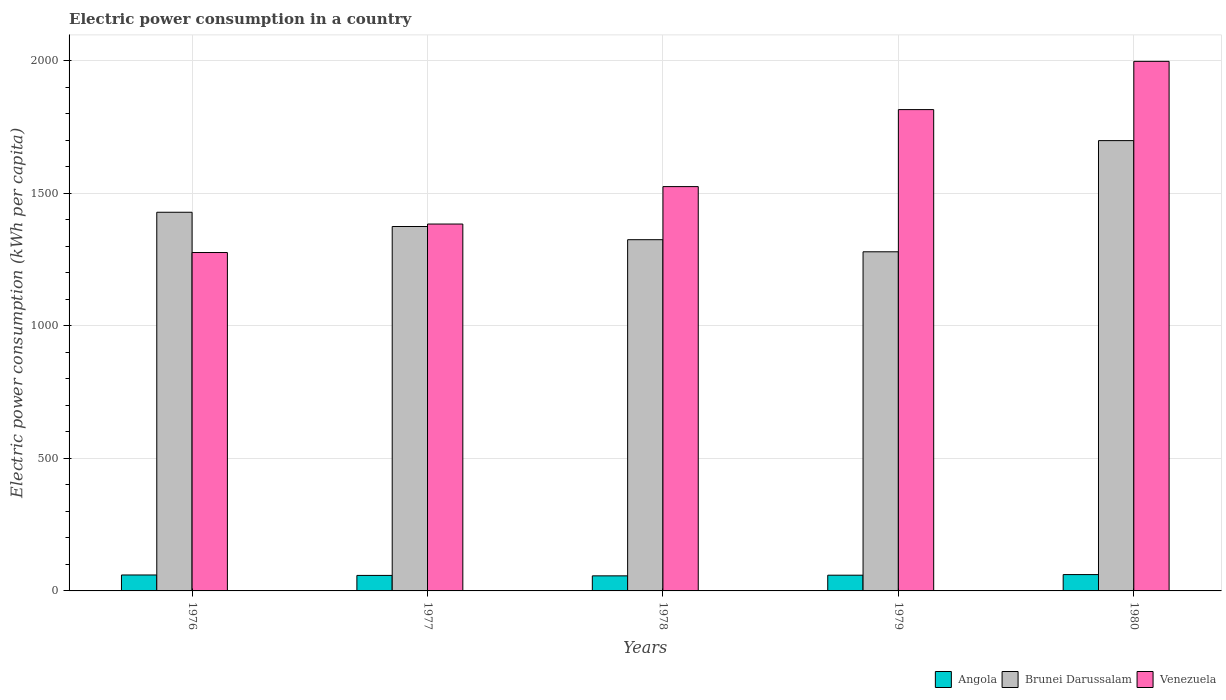How many different coloured bars are there?
Offer a terse response. 3. How many groups of bars are there?
Your answer should be very brief. 5. Are the number of bars per tick equal to the number of legend labels?
Keep it short and to the point. Yes. What is the label of the 1st group of bars from the left?
Your answer should be very brief. 1976. In how many cases, is the number of bars for a given year not equal to the number of legend labels?
Your response must be concise. 0. What is the electric power consumption in in Angola in 1977?
Give a very brief answer. 58.52. Across all years, what is the maximum electric power consumption in in Brunei Darussalam?
Make the answer very short. 1698.98. Across all years, what is the minimum electric power consumption in in Venezuela?
Offer a terse response. 1276.79. In which year was the electric power consumption in in Venezuela minimum?
Offer a very short reply. 1976. What is the total electric power consumption in in Angola in the graph?
Give a very brief answer. 296.52. What is the difference between the electric power consumption in in Venezuela in 1977 and that in 1979?
Offer a very short reply. -431.78. What is the difference between the electric power consumption in in Venezuela in 1978 and the electric power consumption in in Angola in 1979?
Offer a very short reply. 1466.13. What is the average electric power consumption in in Angola per year?
Your answer should be compact. 59.3. In the year 1979, what is the difference between the electric power consumption in in Venezuela and electric power consumption in in Brunei Darussalam?
Keep it short and to the point. 536.46. In how many years, is the electric power consumption in in Brunei Darussalam greater than 1100 kWh per capita?
Your answer should be compact. 5. What is the ratio of the electric power consumption in in Brunei Darussalam in 1977 to that in 1979?
Your response must be concise. 1.07. What is the difference between the highest and the second highest electric power consumption in in Brunei Darussalam?
Offer a very short reply. 270.26. What is the difference between the highest and the lowest electric power consumption in in Brunei Darussalam?
Ensure brevity in your answer.  419.44. In how many years, is the electric power consumption in in Angola greater than the average electric power consumption in in Angola taken over all years?
Your answer should be very brief. 3. What does the 3rd bar from the left in 1978 represents?
Your answer should be very brief. Venezuela. What does the 3rd bar from the right in 1979 represents?
Provide a succinct answer. Angola. Are all the bars in the graph horizontal?
Your answer should be compact. No. Are the values on the major ticks of Y-axis written in scientific E-notation?
Ensure brevity in your answer.  No. Does the graph contain any zero values?
Your answer should be very brief. No. Does the graph contain grids?
Offer a terse response. Yes. How are the legend labels stacked?
Your answer should be compact. Horizontal. What is the title of the graph?
Ensure brevity in your answer.  Electric power consumption in a country. Does "Indonesia" appear as one of the legend labels in the graph?
Your answer should be compact. No. What is the label or title of the X-axis?
Ensure brevity in your answer.  Years. What is the label or title of the Y-axis?
Your answer should be very brief. Electric power consumption (kWh per capita). What is the Electric power consumption (kWh per capita) in Angola in 1976?
Your answer should be compact. 60.14. What is the Electric power consumption (kWh per capita) in Brunei Darussalam in 1976?
Offer a very short reply. 1428.72. What is the Electric power consumption (kWh per capita) in Venezuela in 1976?
Keep it short and to the point. 1276.79. What is the Electric power consumption (kWh per capita) in Angola in 1977?
Give a very brief answer. 58.52. What is the Electric power consumption (kWh per capita) of Brunei Darussalam in 1977?
Your response must be concise. 1374.94. What is the Electric power consumption (kWh per capita) of Venezuela in 1977?
Provide a short and direct response. 1384.22. What is the Electric power consumption (kWh per capita) in Angola in 1978?
Offer a terse response. 56.89. What is the Electric power consumption (kWh per capita) of Brunei Darussalam in 1978?
Ensure brevity in your answer.  1325.15. What is the Electric power consumption (kWh per capita) of Venezuela in 1978?
Keep it short and to the point. 1525.48. What is the Electric power consumption (kWh per capita) in Angola in 1979?
Offer a terse response. 59.35. What is the Electric power consumption (kWh per capita) in Brunei Darussalam in 1979?
Ensure brevity in your answer.  1279.54. What is the Electric power consumption (kWh per capita) of Venezuela in 1979?
Your answer should be compact. 1816. What is the Electric power consumption (kWh per capita) in Angola in 1980?
Offer a very short reply. 61.62. What is the Electric power consumption (kWh per capita) of Brunei Darussalam in 1980?
Your answer should be very brief. 1698.98. What is the Electric power consumption (kWh per capita) of Venezuela in 1980?
Your answer should be very brief. 1998.06. Across all years, what is the maximum Electric power consumption (kWh per capita) of Angola?
Keep it short and to the point. 61.62. Across all years, what is the maximum Electric power consumption (kWh per capita) of Brunei Darussalam?
Your answer should be very brief. 1698.98. Across all years, what is the maximum Electric power consumption (kWh per capita) of Venezuela?
Your response must be concise. 1998.06. Across all years, what is the minimum Electric power consumption (kWh per capita) in Angola?
Your answer should be compact. 56.89. Across all years, what is the minimum Electric power consumption (kWh per capita) in Brunei Darussalam?
Offer a very short reply. 1279.54. Across all years, what is the minimum Electric power consumption (kWh per capita) in Venezuela?
Provide a short and direct response. 1276.79. What is the total Electric power consumption (kWh per capita) in Angola in the graph?
Provide a succinct answer. 296.52. What is the total Electric power consumption (kWh per capita) in Brunei Darussalam in the graph?
Give a very brief answer. 7107.32. What is the total Electric power consumption (kWh per capita) of Venezuela in the graph?
Offer a terse response. 8000.54. What is the difference between the Electric power consumption (kWh per capita) in Angola in 1976 and that in 1977?
Offer a very short reply. 1.62. What is the difference between the Electric power consumption (kWh per capita) in Brunei Darussalam in 1976 and that in 1977?
Provide a short and direct response. 53.78. What is the difference between the Electric power consumption (kWh per capita) of Venezuela in 1976 and that in 1977?
Your answer should be compact. -107.43. What is the difference between the Electric power consumption (kWh per capita) in Angola in 1976 and that in 1978?
Provide a short and direct response. 3.25. What is the difference between the Electric power consumption (kWh per capita) in Brunei Darussalam in 1976 and that in 1978?
Your response must be concise. 103.57. What is the difference between the Electric power consumption (kWh per capita) of Venezuela in 1976 and that in 1978?
Provide a short and direct response. -248.69. What is the difference between the Electric power consumption (kWh per capita) of Angola in 1976 and that in 1979?
Offer a terse response. 0.79. What is the difference between the Electric power consumption (kWh per capita) of Brunei Darussalam in 1976 and that in 1979?
Offer a very short reply. 149.18. What is the difference between the Electric power consumption (kWh per capita) of Venezuela in 1976 and that in 1979?
Make the answer very short. -539.21. What is the difference between the Electric power consumption (kWh per capita) in Angola in 1976 and that in 1980?
Provide a succinct answer. -1.48. What is the difference between the Electric power consumption (kWh per capita) of Brunei Darussalam in 1976 and that in 1980?
Keep it short and to the point. -270.26. What is the difference between the Electric power consumption (kWh per capita) of Venezuela in 1976 and that in 1980?
Offer a terse response. -721.27. What is the difference between the Electric power consumption (kWh per capita) in Angola in 1977 and that in 1978?
Ensure brevity in your answer.  1.64. What is the difference between the Electric power consumption (kWh per capita) in Brunei Darussalam in 1977 and that in 1978?
Your answer should be very brief. 49.79. What is the difference between the Electric power consumption (kWh per capita) in Venezuela in 1977 and that in 1978?
Make the answer very short. -141.26. What is the difference between the Electric power consumption (kWh per capita) in Angola in 1977 and that in 1979?
Give a very brief answer. -0.83. What is the difference between the Electric power consumption (kWh per capita) in Brunei Darussalam in 1977 and that in 1979?
Give a very brief answer. 95.4. What is the difference between the Electric power consumption (kWh per capita) of Venezuela in 1977 and that in 1979?
Your answer should be compact. -431.77. What is the difference between the Electric power consumption (kWh per capita) in Angola in 1977 and that in 1980?
Your answer should be compact. -3.09. What is the difference between the Electric power consumption (kWh per capita) in Brunei Darussalam in 1977 and that in 1980?
Your answer should be compact. -324.04. What is the difference between the Electric power consumption (kWh per capita) of Venezuela in 1977 and that in 1980?
Offer a terse response. -613.83. What is the difference between the Electric power consumption (kWh per capita) in Angola in 1978 and that in 1979?
Keep it short and to the point. -2.46. What is the difference between the Electric power consumption (kWh per capita) in Brunei Darussalam in 1978 and that in 1979?
Make the answer very short. 45.61. What is the difference between the Electric power consumption (kWh per capita) of Venezuela in 1978 and that in 1979?
Provide a short and direct response. -290.52. What is the difference between the Electric power consumption (kWh per capita) in Angola in 1978 and that in 1980?
Provide a succinct answer. -4.73. What is the difference between the Electric power consumption (kWh per capita) of Brunei Darussalam in 1978 and that in 1980?
Offer a very short reply. -373.83. What is the difference between the Electric power consumption (kWh per capita) in Venezuela in 1978 and that in 1980?
Your answer should be very brief. -472.58. What is the difference between the Electric power consumption (kWh per capita) in Angola in 1979 and that in 1980?
Ensure brevity in your answer.  -2.27. What is the difference between the Electric power consumption (kWh per capita) of Brunei Darussalam in 1979 and that in 1980?
Give a very brief answer. -419.44. What is the difference between the Electric power consumption (kWh per capita) in Venezuela in 1979 and that in 1980?
Ensure brevity in your answer.  -182.06. What is the difference between the Electric power consumption (kWh per capita) of Angola in 1976 and the Electric power consumption (kWh per capita) of Brunei Darussalam in 1977?
Provide a short and direct response. -1314.8. What is the difference between the Electric power consumption (kWh per capita) in Angola in 1976 and the Electric power consumption (kWh per capita) in Venezuela in 1977?
Make the answer very short. -1324.08. What is the difference between the Electric power consumption (kWh per capita) of Brunei Darussalam in 1976 and the Electric power consumption (kWh per capita) of Venezuela in 1977?
Your answer should be compact. 44.49. What is the difference between the Electric power consumption (kWh per capita) in Angola in 1976 and the Electric power consumption (kWh per capita) in Brunei Darussalam in 1978?
Your answer should be compact. -1265.01. What is the difference between the Electric power consumption (kWh per capita) of Angola in 1976 and the Electric power consumption (kWh per capita) of Venezuela in 1978?
Your answer should be very brief. -1465.34. What is the difference between the Electric power consumption (kWh per capita) in Brunei Darussalam in 1976 and the Electric power consumption (kWh per capita) in Venezuela in 1978?
Provide a short and direct response. -96.76. What is the difference between the Electric power consumption (kWh per capita) of Angola in 1976 and the Electric power consumption (kWh per capita) of Brunei Darussalam in 1979?
Offer a very short reply. -1219.4. What is the difference between the Electric power consumption (kWh per capita) of Angola in 1976 and the Electric power consumption (kWh per capita) of Venezuela in 1979?
Provide a short and direct response. -1755.86. What is the difference between the Electric power consumption (kWh per capita) in Brunei Darussalam in 1976 and the Electric power consumption (kWh per capita) in Venezuela in 1979?
Offer a terse response. -387.28. What is the difference between the Electric power consumption (kWh per capita) of Angola in 1976 and the Electric power consumption (kWh per capita) of Brunei Darussalam in 1980?
Offer a very short reply. -1638.84. What is the difference between the Electric power consumption (kWh per capita) in Angola in 1976 and the Electric power consumption (kWh per capita) in Venezuela in 1980?
Ensure brevity in your answer.  -1937.91. What is the difference between the Electric power consumption (kWh per capita) of Brunei Darussalam in 1976 and the Electric power consumption (kWh per capita) of Venezuela in 1980?
Keep it short and to the point. -569.34. What is the difference between the Electric power consumption (kWh per capita) in Angola in 1977 and the Electric power consumption (kWh per capita) in Brunei Darussalam in 1978?
Provide a succinct answer. -1266.63. What is the difference between the Electric power consumption (kWh per capita) in Angola in 1977 and the Electric power consumption (kWh per capita) in Venezuela in 1978?
Give a very brief answer. -1466.96. What is the difference between the Electric power consumption (kWh per capita) in Brunei Darussalam in 1977 and the Electric power consumption (kWh per capita) in Venezuela in 1978?
Give a very brief answer. -150.54. What is the difference between the Electric power consumption (kWh per capita) in Angola in 1977 and the Electric power consumption (kWh per capita) in Brunei Darussalam in 1979?
Offer a terse response. -1221.02. What is the difference between the Electric power consumption (kWh per capita) of Angola in 1977 and the Electric power consumption (kWh per capita) of Venezuela in 1979?
Offer a terse response. -1757.47. What is the difference between the Electric power consumption (kWh per capita) in Brunei Darussalam in 1977 and the Electric power consumption (kWh per capita) in Venezuela in 1979?
Your answer should be compact. -441.06. What is the difference between the Electric power consumption (kWh per capita) of Angola in 1977 and the Electric power consumption (kWh per capita) of Brunei Darussalam in 1980?
Offer a very short reply. -1640.46. What is the difference between the Electric power consumption (kWh per capita) of Angola in 1977 and the Electric power consumption (kWh per capita) of Venezuela in 1980?
Give a very brief answer. -1939.53. What is the difference between the Electric power consumption (kWh per capita) of Brunei Darussalam in 1977 and the Electric power consumption (kWh per capita) of Venezuela in 1980?
Your response must be concise. -623.12. What is the difference between the Electric power consumption (kWh per capita) of Angola in 1978 and the Electric power consumption (kWh per capita) of Brunei Darussalam in 1979?
Ensure brevity in your answer.  -1222.65. What is the difference between the Electric power consumption (kWh per capita) of Angola in 1978 and the Electric power consumption (kWh per capita) of Venezuela in 1979?
Your answer should be compact. -1759.11. What is the difference between the Electric power consumption (kWh per capita) in Brunei Darussalam in 1978 and the Electric power consumption (kWh per capita) in Venezuela in 1979?
Make the answer very short. -490.85. What is the difference between the Electric power consumption (kWh per capita) in Angola in 1978 and the Electric power consumption (kWh per capita) in Brunei Darussalam in 1980?
Give a very brief answer. -1642.09. What is the difference between the Electric power consumption (kWh per capita) of Angola in 1978 and the Electric power consumption (kWh per capita) of Venezuela in 1980?
Offer a terse response. -1941.17. What is the difference between the Electric power consumption (kWh per capita) in Brunei Darussalam in 1978 and the Electric power consumption (kWh per capita) in Venezuela in 1980?
Make the answer very short. -672.91. What is the difference between the Electric power consumption (kWh per capita) of Angola in 1979 and the Electric power consumption (kWh per capita) of Brunei Darussalam in 1980?
Provide a short and direct response. -1639.63. What is the difference between the Electric power consumption (kWh per capita) in Angola in 1979 and the Electric power consumption (kWh per capita) in Venezuela in 1980?
Provide a succinct answer. -1938.71. What is the difference between the Electric power consumption (kWh per capita) of Brunei Darussalam in 1979 and the Electric power consumption (kWh per capita) of Venezuela in 1980?
Offer a terse response. -718.52. What is the average Electric power consumption (kWh per capita) of Angola per year?
Offer a terse response. 59.3. What is the average Electric power consumption (kWh per capita) of Brunei Darussalam per year?
Provide a short and direct response. 1421.46. What is the average Electric power consumption (kWh per capita) of Venezuela per year?
Ensure brevity in your answer.  1600.11. In the year 1976, what is the difference between the Electric power consumption (kWh per capita) of Angola and Electric power consumption (kWh per capita) of Brunei Darussalam?
Your answer should be very brief. -1368.58. In the year 1976, what is the difference between the Electric power consumption (kWh per capita) in Angola and Electric power consumption (kWh per capita) in Venezuela?
Your response must be concise. -1216.65. In the year 1976, what is the difference between the Electric power consumption (kWh per capita) in Brunei Darussalam and Electric power consumption (kWh per capita) in Venezuela?
Make the answer very short. 151.93. In the year 1977, what is the difference between the Electric power consumption (kWh per capita) in Angola and Electric power consumption (kWh per capita) in Brunei Darussalam?
Make the answer very short. -1316.42. In the year 1977, what is the difference between the Electric power consumption (kWh per capita) in Angola and Electric power consumption (kWh per capita) in Venezuela?
Give a very brief answer. -1325.7. In the year 1977, what is the difference between the Electric power consumption (kWh per capita) of Brunei Darussalam and Electric power consumption (kWh per capita) of Venezuela?
Give a very brief answer. -9.28. In the year 1978, what is the difference between the Electric power consumption (kWh per capita) of Angola and Electric power consumption (kWh per capita) of Brunei Darussalam?
Your answer should be compact. -1268.26. In the year 1978, what is the difference between the Electric power consumption (kWh per capita) in Angola and Electric power consumption (kWh per capita) in Venezuela?
Give a very brief answer. -1468.59. In the year 1978, what is the difference between the Electric power consumption (kWh per capita) of Brunei Darussalam and Electric power consumption (kWh per capita) of Venezuela?
Your response must be concise. -200.33. In the year 1979, what is the difference between the Electric power consumption (kWh per capita) in Angola and Electric power consumption (kWh per capita) in Brunei Darussalam?
Offer a terse response. -1220.19. In the year 1979, what is the difference between the Electric power consumption (kWh per capita) in Angola and Electric power consumption (kWh per capita) in Venezuela?
Your answer should be compact. -1756.65. In the year 1979, what is the difference between the Electric power consumption (kWh per capita) in Brunei Darussalam and Electric power consumption (kWh per capita) in Venezuela?
Your answer should be very brief. -536.46. In the year 1980, what is the difference between the Electric power consumption (kWh per capita) in Angola and Electric power consumption (kWh per capita) in Brunei Darussalam?
Give a very brief answer. -1637.36. In the year 1980, what is the difference between the Electric power consumption (kWh per capita) in Angola and Electric power consumption (kWh per capita) in Venezuela?
Keep it short and to the point. -1936.44. In the year 1980, what is the difference between the Electric power consumption (kWh per capita) of Brunei Darussalam and Electric power consumption (kWh per capita) of Venezuela?
Give a very brief answer. -299.08. What is the ratio of the Electric power consumption (kWh per capita) in Angola in 1976 to that in 1977?
Your answer should be compact. 1.03. What is the ratio of the Electric power consumption (kWh per capita) of Brunei Darussalam in 1976 to that in 1977?
Your response must be concise. 1.04. What is the ratio of the Electric power consumption (kWh per capita) of Venezuela in 1976 to that in 1977?
Give a very brief answer. 0.92. What is the ratio of the Electric power consumption (kWh per capita) of Angola in 1976 to that in 1978?
Offer a very short reply. 1.06. What is the ratio of the Electric power consumption (kWh per capita) of Brunei Darussalam in 1976 to that in 1978?
Offer a very short reply. 1.08. What is the ratio of the Electric power consumption (kWh per capita) of Venezuela in 1976 to that in 1978?
Make the answer very short. 0.84. What is the ratio of the Electric power consumption (kWh per capita) of Angola in 1976 to that in 1979?
Offer a very short reply. 1.01. What is the ratio of the Electric power consumption (kWh per capita) in Brunei Darussalam in 1976 to that in 1979?
Your response must be concise. 1.12. What is the ratio of the Electric power consumption (kWh per capita) in Venezuela in 1976 to that in 1979?
Your response must be concise. 0.7. What is the ratio of the Electric power consumption (kWh per capita) in Brunei Darussalam in 1976 to that in 1980?
Provide a short and direct response. 0.84. What is the ratio of the Electric power consumption (kWh per capita) in Venezuela in 1976 to that in 1980?
Offer a terse response. 0.64. What is the ratio of the Electric power consumption (kWh per capita) in Angola in 1977 to that in 1978?
Offer a very short reply. 1.03. What is the ratio of the Electric power consumption (kWh per capita) of Brunei Darussalam in 1977 to that in 1978?
Make the answer very short. 1.04. What is the ratio of the Electric power consumption (kWh per capita) of Venezuela in 1977 to that in 1978?
Give a very brief answer. 0.91. What is the ratio of the Electric power consumption (kWh per capita) of Angola in 1977 to that in 1979?
Your response must be concise. 0.99. What is the ratio of the Electric power consumption (kWh per capita) in Brunei Darussalam in 1977 to that in 1979?
Make the answer very short. 1.07. What is the ratio of the Electric power consumption (kWh per capita) of Venezuela in 1977 to that in 1979?
Offer a terse response. 0.76. What is the ratio of the Electric power consumption (kWh per capita) of Angola in 1977 to that in 1980?
Make the answer very short. 0.95. What is the ratio of the Electric power consumption (kWh per capita) in Brunei Darussalam in 1977 to that in 1980?
Ensure brevity in your answer.  0.81. What is the ratio of the Electric power consumption (kWh per capita) of Venezuela in 1977 to that in 1980?
Ensure brevity in your answer.  0.69. What is the ratio of the Electric power consumption (kWh per capita) of Angola in 1978 to that in 1979?
Offer a very short reply. 0.96. What is the ratio of the Electric power consumption (kWh per capita) in Brunei Darussalam in 1978 to that in 1979?
Your answer should be compact. 1.04. What is the ratio of the Electric power consumption (kWh per capita) of Venezuela in 1978 to that in 1979?
Provide a short and direct response. 0.84. What is the ratio of the Electric power consumption (kWh per capita) in Angola in 1978 to that in 1980?
Your answer should be compact. 0.92. What is the ratio of the Electric power consumption (kWh per capita) of Brunei Darussalam in 1978 to that in 1980?
Give a very brief answer. 0.78. What is the ratio of the Electric power consumption (kWh per capita) of Venezuela in 1978 to that in 1980?
Your response must be concise. 0.76. What is the ratio of the Electric power consumption (kWh per capita) of Angola in 1979 to that in 1980?
Ensure brevity in your answer.  0.96. What is the ratio of the Electric power consumption (kWh per capita) in Brunei Darussalam in 1979 to that in 1980?
Offer a terse response. 0.75. What is the ratio of the Electric power consumption (kWh per capita) in Venezuela in 1979 to that in 1980?
Give a very brief answer. 0.91. What is the difference between the highest and the second highest Electric power consumption (kWh per capita) of Angola?
Keep it short and to the point. 1.48. What is the difference between the highest and the second highest Electric power consumption (kWh per capita) of Brunei Darussalam?
Your answer should be compact. 270.26. What is the difference between the highest and the second highest Electric power consumption (kWh per capita) of Venezuela?
Offer a very short reply. 182.06. What is the difference between the highest and the lowest Electric power consumption (kWh per capita) in Angola?
Keep it short and to the point. 4.73. What is the difference between the highest and the lowest Electric power consumption (kWh per capita) of Brunei Darussalam?
Make the answer very short. 419.44. What is the difference between the highest and the lowest Electric power consumption (kWh per capita) in Venezuela?
Provide a short and direct response. 721.27. 